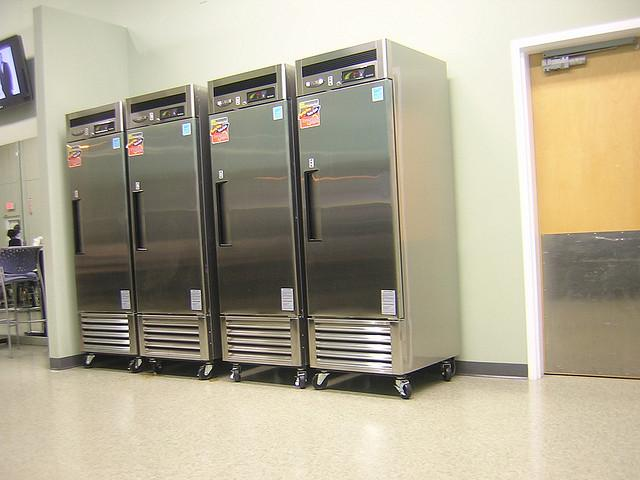What temperature do these devices keep things? Please explain your reasoning. cold. They are refrigerators to keep food cold in order to preserve it. 